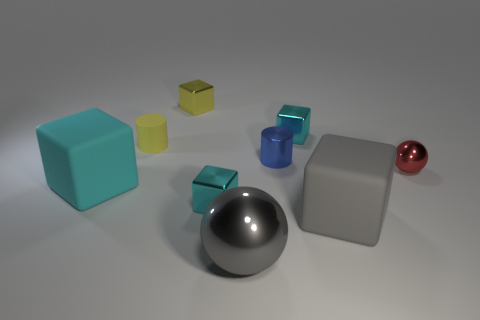How many cyan cubes must be subtracted to get 1 cyan cubes? 2 Subtract all yellow cylinders. How many cyan blocks are left? 3 Subtract all gray rubber blocks. How many blocks are left? 4 Subtract all yellow cubes. How many cubes are left? 4 Add 1 blue metal things. How many objects exist? 10 Subtract all cylinders. How many objects are left? 7 Subtract all yellow blocks. Subtract all blue spheres. How many blocks are left? 4 Add 1 cylinders. How many cylinders exist? 3 Subtract 1 blue cylinders. How many objects are left? 8 Subtract all small blue metallic things. Subtract all small metallic cylinders. How many objects are left? 7 